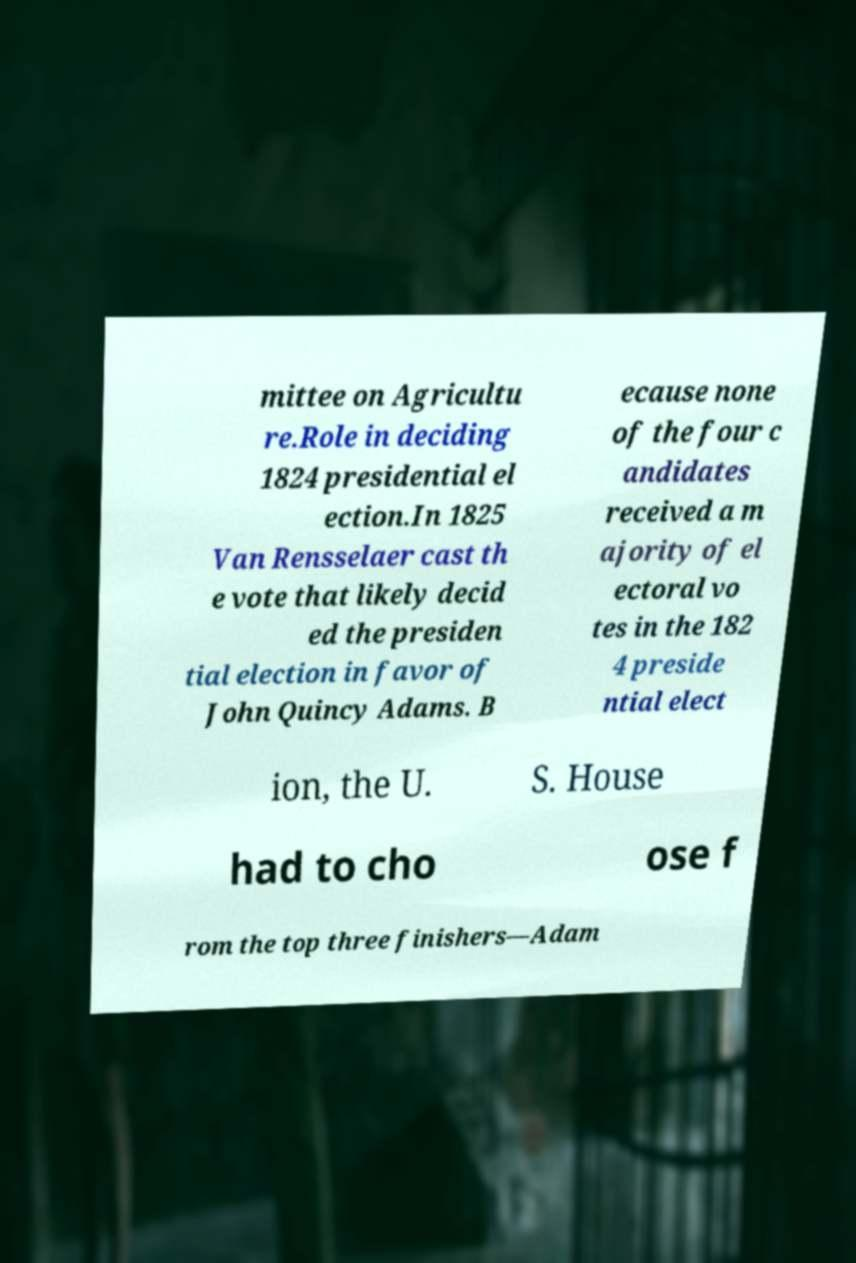Please identify and transcribe the text found in this image. mittee on Agricultu re.Role in deciding 1824 presidential el ection.In 1825 Van Rensselaer cast th e vote that likely decid ed the presiden tial election in favor of John Quincy Adams. B ecause none of the four c andidates received a m ajority of el ectoral vo tes in the 182 4 preside ntial elect ion, the U. S. House had to cho ose f rom the top three finishers—Adam 